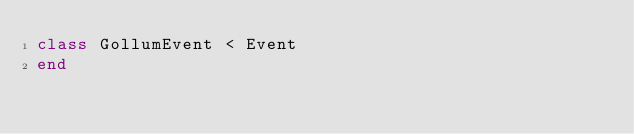<code> <loc_0><loc_0><loc_500><loc_500><_Ruby_>class GollumEvent < Event
end
</code> 